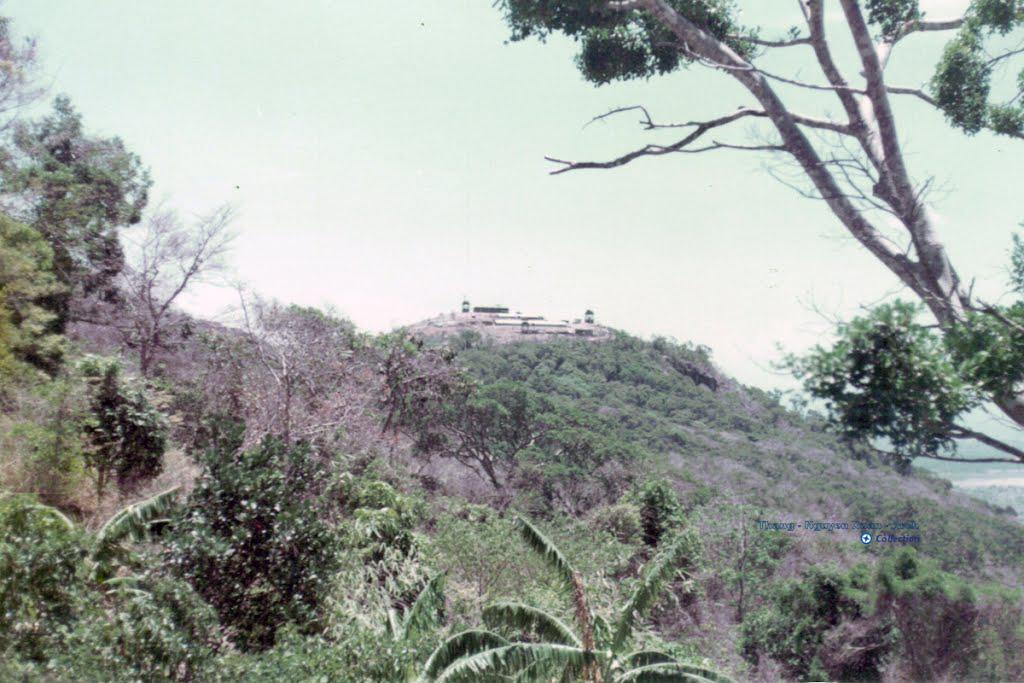What type of natural elements can be seen in the image? There are trees in the image. What geographical feature is present in the image? There is a hill in the image. What else can be seen in the image besides the trees and hill? There are objects in the image. What is visible in the background of the image? The sky is visible in the background of the image. Where is the library located in the image? There is no library present in the image. How many snakes are slithering on the hill in the image? There are no snakes visible in the image. 